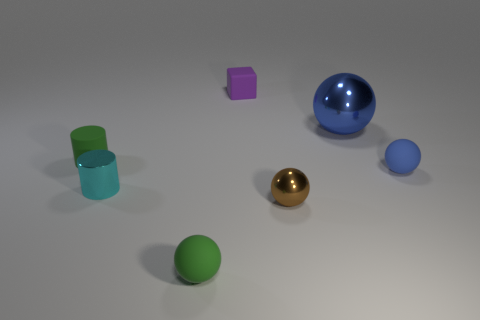Can you tell me the material that the objects in the image are made from? The objects in the image resemble various geometric shapes, and they appear to be rendered with different materials. The shiny gold and shiny blue objects likely represent metal and glass respectively in terms of realistic materials, due to their reflective properties. Meanwhile, the other objects could represent plastic or ceramic, given their matte and slightly reflective surfaces. 